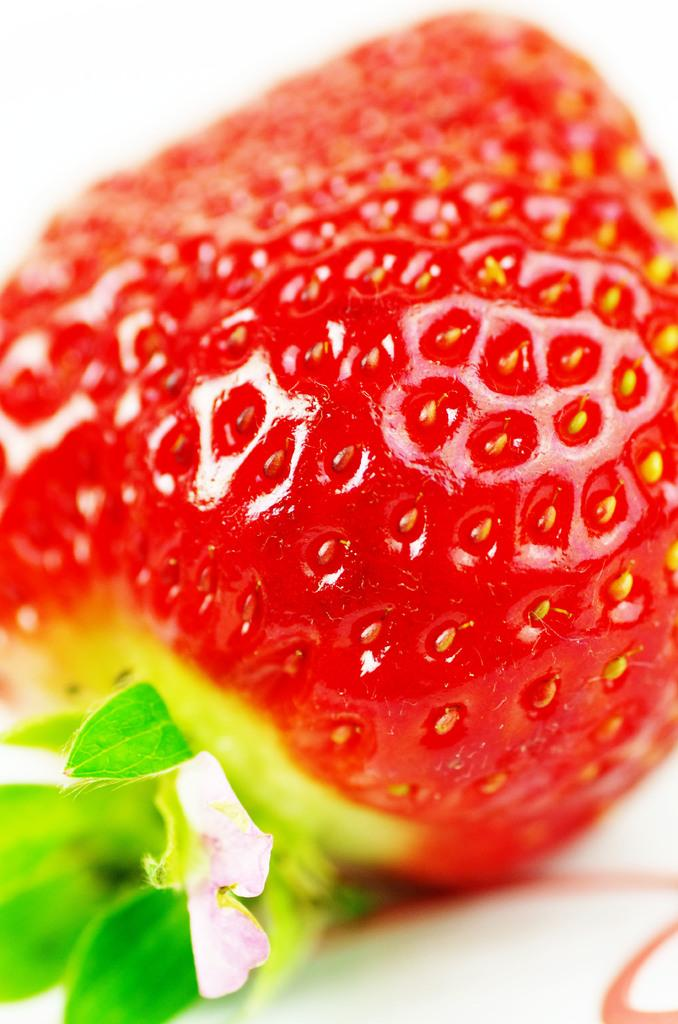What type of fruit is present in the image? There is a strawberry in the image. What type of territory does the owl claim in the image? There is no owl or territory present in the image; it only features a strawberry. 